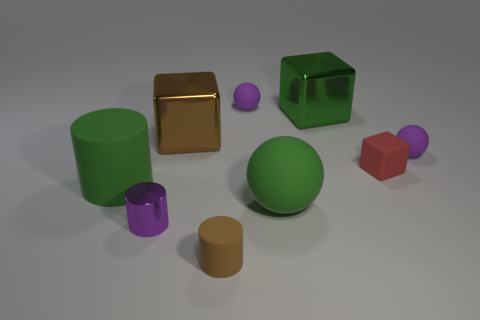Is there anything else that has the same color as the large matte ball?
Offer a very short reply. Yes. Is the object that is to the right of the small red thing made of the same material as the brown cube?
Provide a succinct answer. No. How many small matte objects are in front of the tiny metal cylinder and behind the big green metallic object?
Your response must be concise. 0. What size is the metal cylinder in front of the big metal cube that is to the right of the tiny brown rubber cylinder?
Your answer should be very brief. Small. Are there any other things that have the same material as the big green block?
Make the answer very short. Yes. Is the number of big cyan matte spheres greater than the number of tiny rubber cylinders?
Offer a very short reply. No. Does the tiny rubber sphere that is on the right side of the small red rubber object have the same color as the big matte object to the right of the small brown cylinder?
Make the answer very short. No. Are there any big shiny objects on the left side of the thing behind the big green metallic object?
Offer a very short reply. Yes. Are there fewer green matte things in front of the brown matte thing than brown metallic cubes that are on the right side of the green block?
Your answer should be compact. No. Do the thing behind the big green cube and the thing on the right side of the red rubber object have the same material?
Your answer should be very brief. Yes. 